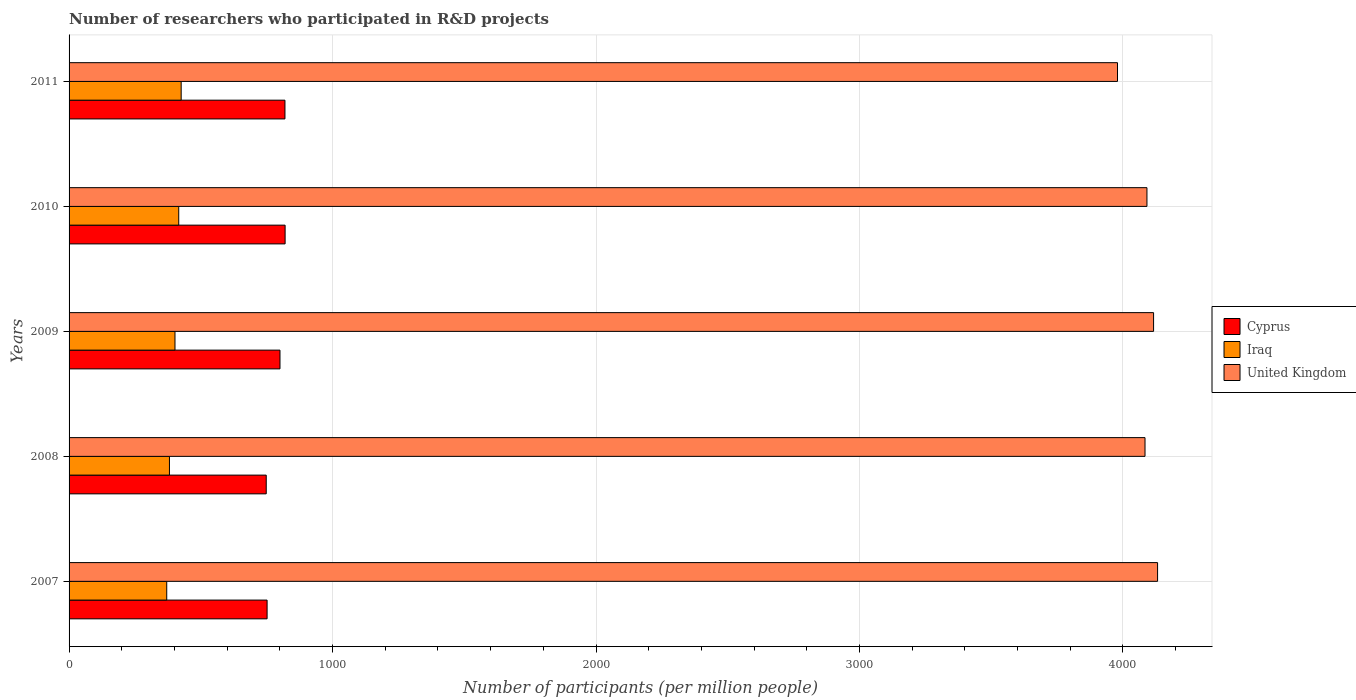How many groups of bars are there?
Your response must be concise. 5. Are the number of bars per tick equal to the number of legend labels?
Offer a very short reply. Yes. How many bars are there on the 2nd tick from the bottom?
Offer a terse response. 3. What is the label of the 4th group of bars from the top?
Your answer should be very brief. 2008. In how many cases, is the number of bars for a given year not equal to the number of legend labels?
Give a very brief answer. 0. What is the number of researchers who participated in R&D projects in United Kingdom in 2010?
Provide a succinct answer. 4091.18. Across all years, what is the maximum number of researchers who participated in R&D projects in United Kingdom?
Offer a terse response. 4131.53. Across all years, what is the minimum number of researchers who participated in R&D projects in Iraq?
Provide a succinct answer. 370.71. In which year was the number of researchers who participated in R&D projects in Cyprus maximum?
Offer a terse response. 2010. What is the total number of researchers who participated in R&D projects in Cyprus in the graph?
Give a very brief answer. 3939.95. What is the difference between the number of researchers who participated in R&D projects in United Kingdom in 2008 and that in 2010?
Provide a short and direct response. -7.32. What is the difference between the number of researchers who participated in R&D projects in Iraq in 2010 and the number of researchers who participated in R&D projects in United Kingdom in 2008?
Provide a succinct answer. -3667.6. What is the average number of researchers who participated in R&D projects in Cyprus per year?
Provide a short and direct response. 787.99. In the year 2011, what is the difference between the number of researchers who participated in R&D projects in United Kingdom and number of researchers who participated in R&D projects in Iraq?
Your answer should be compact. 3553.91. What is the ratio of the number of researchers who participated in R&D projects in Cyprus in 2008 to that in 2010?
Offer a very short reply. 0.91. Is the number of researchers who participated in R&D projects in Iraq in 2009 less than that in 2010?
Give a very brief answer. Yes. What is the difference between the highest and the second highest number of researchers who participated in R&D projects in Cyprus?
Provide a short and direct response. 0.56. What is the difference between the highest and the lowest number of researchers who participated in R&D projects in Cyprus?
Your response must be concise. 71.61. Is the sum of the number of researchers who participated in R&D projects in Cyprus in 2007 and 2011 greater than the maximum number of researchers who participated in R&D projects in United Kingdom across all years?
Your answer should be very brief. No. What does the 3rd bar from the top in 2007 represents?
Keep it short and to the point. Cyprus. What does the 3rd bar from the bottom in 2011 represents?
Offer a terse response. United Kingdom. Are the values on the major ticks of X-axis written in scientific E-notation?
Ensure brevity in your answer.  No. Does the graph contain any zero values?
Provide a succinct answer. No. Where does the legend appear in the graph?
Your response must be concise. Center right. How many legend labels are there?
Make the answer very short. 3. How are the legend labels stacked?
Ensure brevity in your answer.  Vertical. What is the title of the graph?
Your answer should be compact. Number of researchers who participated in R&D projects. Does "Timor-Leste" appear as one of the legend labels in the graph?
Offer a very short reply. No. What is the label or title of the X-axis?
Ensure brevity in your answer.  Number of participants (per million people). What is the label or title of the Y-axis?
Keep it short and to the point. Years. What is the Number of participants (per million people) of Cyprus in 2007?
Your answer should be very brief. 751.62. What is the Number of participants (per million people) in Iraq in 2007?
Offer a terse response. 370.71. What is the Number of participants (per million people) in United Kingdom in 2007?
Ensure brevity in your answer.  4131.53. What is the Number of participants (per million people) of Cyprus in 2008?
Keep it short and to the point. 748.37. What is the Number of participants (per million people) of Iraq in 2008?
Provide a succinct answer. 381.03. What is the Number of participants (per million people) of United Kingdom in 2008?
Your answer should be compact. 4083.86. What is the Number of participants (per million people) of Cyprus in 2009?
Your answer should be very brief. 800.56. What is the Number of participants (per million people) in Iraq in 2009?
Offer a terse response. 401.99. What is the Number of participants (per million people) of United Kingdom in 2009?
Offer a terse response. 4116.35. What is the Number of participants (per million people) of Cyprus in 2010?
Offer a very short reply. 819.98. What is the Number of participants (per million people) of Iraq in 2010?
Your response must be concise. 416.25. What is the Number of participants (per million people) in United Kingdom in 2010?
Your answer should be compact. 4091.18. What is the Number of participants (per million people) in Cyprus in 2011?
Give a very brief answer. 819.42. What is the Number of participants (per million people) of Iraq in 2011?
Provide a short and direct response. 425.48. What is the Number of participants (per million people) in United Kingdom in 2011?
Make the answer very short. 3979.38. Across all years, what is the maximum Number of participants (per million people) of Cyprus?
Your answer should be very brief. 819.98. Across all years, what is the maximum Number of participants (per million people) of Iraq?
Your answer should be very brief. 425.48. Across all years, what is the maximum Number of participants (per million people) of United Kingdom?
Make the answer very short. 4131.53. Across all years, what is the minimum Number of participants (per million people) in Cyprus?
Keep it short and to the point. 748.37. Across all years, what is the minimum Number of participants (per million people) of Iraq?
Give a very brief answer. 370.71. Across all years, what is the minimum Number of participants (per million people) of United Kingdom?
Keep it short and to the point. 3979.38. What is the total Number of participants (per million people) in Cyprus in the graph?
Make the answer very short. 3939.95. What is the total Number of participants (per million people) in Iraq in the graph?
Your answer should be very brief. 1995.47. What is the total Number of participants (per million people) of United Kingdom in the graph?
Keep it short and to the point. 2.04e+04. What is the difference between the Number of participants (per million people) of Cyprus in 2007 and that in 2008?
Offer a terse response. 3.25. What is the difference between the Number of participants (per million people) of Iraq in 2007 and that in 2008?
Provide a short and direct response. -10.31. What is the difference between the Number of participants (per million people) of United Kingdom in 2007 and that in 2008?
Keep it short and to the point. 47.67. What is the difference between the Number of participants (per million people) in Cyprus in 2007 and that in 2009?
Your answer should be compact. -48.94. What is the difference between the Number of participants (per million people) of Iraq in 2007 and that in 2009?
Your response must be concise. -31.28. What is the difference between the Number of participants (per million people) in United Kingdom in 2007 and that in 2009?
Make the answer very short. 15.18. What is the difference between the Number of participants (per million people) of Cyprus in 2007 and that in 2010?
Ensure brevity in your answer.  -68.36. What is the difference between the Number of participants (per million people) of Iraq in 2007 and that in 2010?
Give a very brief answer. -45.54. What is the difference between the Number of participants (per million people) in United Kingdom in 2007 and that in 2010?
Offer a very short reply. 40.36. What is the difference between the Number of participants (per million people) of Cyprus in 2007 and that in 2011?
Offer a very short reply. -67.8. What is the difference between the Number of participants (per million people) of Iraq in 2007 and that in 2011?
Ensure brevity in your answer.  -54.76. What is the difference between the Number of participants (per million people) of United Kingdom in 2007 and that in 2011?
Provide a succinct answer. 152.15. What is the difference between the Number of participants (per million people) in Cyprus in 2008 and that in 2009?
Your answer should be compact. -52.19. What is the difference between the Number of participants (per million people) of Iraq in 2008 and that in 2009?
Your response must be concise. -20.97. What is the difference between the Number of participants (per million people) in United Kingdom in 2008 and that in 2009?
Ensure brevity in your answer.  -32.49. What is the difference between the Number of participants (per million people) of Cyprus in 2008 and that in 2010?
Your response must be concise. -71.61. What is the difference between the Number of participants (per million people) in Iraq in 2008 and that in 2010?
Provide a succinct answer. -35.23. What is the difference between the Number of participants (per million people) of United Kingdom in 2008 and that in 2010?
Your answer should be compact. -7.32. What is the difference between the Number of participants (per million people) in Cyprus in 2008 and that in 2011?
Provide a succinct answer. -71.05. What is the difference between the Number of participants (per million people) in Iraq in 2008 and that in 2011?
Keep it short and to the point. -44.45. What is the difference between the Number of participants (per million people) of United Kingdom in 2008 and that in 2011?
Provide a succinct answer. 104.48. What is the difference between the Number of participants (per million people) of Cyprus in 2009 and that in 2010?
Give a very brief answer. -19.42. What is the difference between the Number of participants (per million people) in Iraq in 2009 and that in 2010?
Your answer should be compact. -14.26. What is the difference between the Number of participants (per million people) in United Kingdom in 2009 and that in 2010?
Your answer should be compact. 25.17. What is the difference between the Number of participants (per million people) of Cyprus in 2009 and that in 2011?
Give a very brief answer. -18.86. What is the difference between the Number of participants (per million people) of Iraq in 2009 and that in 2011?
Provide a succinct answer. -23.48. What is the difference between the Number of participants (per million people) in United Kingdom in 2009 and that in 2011?
Your answer should be very brief. 136.97. What is the difference between the Number of participants (per million people) in Cyprus in 2010 and that in 2011?
Your answer should be very brief. 0.56. What is the difference between the Number of participants (per million people) in Iraq in 2010 and that in 2011?
Provide a succinct answer. -9.22. What is the difference between the Number of participants (per million people) in United Kingdom in 2010 and that in 2011?
Give a very brief answer. 111.79. What is the difference between the Number of participants (per million people) in Cyprus in 2007 and the Number of participants (per million people) in Iraq in 2008?
Provide a succinct answer. 370.59. What is the difference between the Number of participants (per million people) of Cyprus in 2007 and the Number of participants (per million people) of United Kingdom in 2008?
Ensure brevity in your answer.  -3332.24. What is the difference between the Number of participants (per million people) of Iraq in 2007 and the Number of participants (per million people) of United Kingdom in 2008?
Provide a short and direct response. -3713.14. What is the difference between the Number of participants (per million people) of Cyprus in 2007 and the Number of participants (per million people) of Iraq in 2009?
Offer a very short reply. 349.62. What is the difference between the Number of participants (per million people) in Cyprus in 2007 and the Number of participants (per million people) in United Kingdom in 2009?
Keep it short and to the point. -3364.73. What is the difference between the Number of participants (per million people) in Iraq in 2007 and the Number of participants (per million people) in United Kingdom in 2009?
Give a very brief answer. -3745.64. What is the difference between the Number of participants (per million people) in Cyprus in 2007 and the Number of participants (per million people) in Iraq in 2010?
Provide a succinct answer. 335.36. What is the difference between the Number of participants (per million people) of Cyprus in 2007 and the Number of participants (per million people) of United Kingdom in 2010?
Give a very brief answer. -3339.56. What is the difference between the Number of participants (per million people) of Iraq in 2007 and the Number of participants (per million people) of United Kingdom in 2010?
Ensure brevity in your answer.  -3720.46. What is the difference between the Number of participants (per million people) in Cyprus in 2007 and the Number of participants (per million people) in Iraq in 2011?
Keep it short and to the point. 326.14. What is the difference between the Number of participants (per million people) in Cyprus in 2007 and the Number of participants (per million people) in United Kingdom in 2011?
Give a very brief answer. -3227.77. What is the difference between the Number of participants (per million people) in Iraq in 2007 and the Number of participants (per million people) in United Kingdom in 2011?
Make the answer very short. -3608.67. What is the difference between the Number of participants (per million people) of Cyprus in 2008 and the Number of participants (per million people) of Iraq in 2009?
Keep it short and to the point. 346.37. What is the difference between the Number of participants (per million people) of Cyprus in 2008 and the Number of participants (per million people) of United Kingdom in 2009?
Offer a very short reply. -3367.98. What is the difference between the Number of participants (per million people) of Iraq in 2008 and the Number of participants (per million people) of United Kingdom in 2009?
Provide a short and direct response. -3735.32. What is the difference between the Number of participants (per million people) of Cyprus in 2008 and the Number of participants (per million people) of Iraq in 2010?
Provide a short and direct response. 332.11. What is the difference between the Number of participants (per million people) in Cyprus in 2008 and the Number of participants (per million people) in United Kingdom in 2010?
Offer a terse response. -3342.81. What is the difference between the Number of participants (per million people) of Iraq in 2008 and the Number of participants (per million people) of United Kingdom in 2010?
Provide a succinct answer. -3710.15. What is the difference between the Number of participants (per million people) in Cyprus in 2008 and the Number of participants (per million people) in Iraq in 2011?
Keep it short and to the point. 322.89. What is the difference between the Number of participants (per million people) of Cyprus in 2008 and the Number of participants (per million people) of United Kingdom in 2011?
Keep it short and to the point. -3231.02. What is the difference between the Number of participants (per million people) in Iraq in 2008 and the Number of participants (per million people) in United Kingdom in 2011?
Keep it short and to the point. -3598.36. What is the difference between the Number of participants (per million people) of Cyprus in 2009 and the Number of participants (per million people) of Iraq in 2010?
Your answer should be very brief. 384.31. What is the difference between the Number of participants (per million people) in Cyprus in 2009 and the Number of participants (per million people) in United Kingdom in 2010?
Your answer should be very brief. -3290.61. What is the difference between the Number of participants (per million people) of Iraq in 2009 and the Number of participants (per million people) of United Kingdom in 2010?
Provide a short and direct response. -3689.18. What is the difference between the Number of participants (per million people) in Cyprus in 2009 and the Number of participants (per million people) in Iraq in 2011?
Your answer should be very brief. 375.08. What is the difference between the Number of participants (per million people) in Cyprus in 2009 and the Number of participants (per million people) in United Kingdom in 2011?
Your response must be concise. -3178.82. What is the difference between the Number of participants (per million people) of Iraq in 2009 and the Number of participants (per million people) of United Kingdom in 2011?
Give a very brief answer. -3577.39. What is the difference between the Number of participants (per million people) of Cyprus in 2010 and the Number of participants (per million people) of Iraq in 2011?
Offer a very short reply. 394.5. What is the difference between the Number of participants (per million people) of Cyprus in 2010 and the Number of participants (per million people) of United Kingdom in 2011?
Make the answer very short. -3159.4. What is the difference between the Number of participants (per million people) of Iraq in 2010 and the Number of participants (per million people) of United Kingdom in 2011?
Offer a very short reply. -3563.13. What is the average Number of participants (per million people) in Cyprus per year?
Make the answer very short. 787.99. What is the average Number of participants (per million people) in Iraq per year?
Your response must be concise. 399.09. What is the average Number of participants (per million people) of United Kingdom per year?
Ensure brevity in your answer.  4080.46. In the year 2007, what is the difference between the Number of participants (per million people) of Cyprus and Number of participants (per million people) of Iraq?
Offer a terse response. 380.9. In the year 2007, what is the difference between the Number of participants (per million people) in Cyprus and Number of participants (per million people) in United Kingdom?
Offer a terse response. -3379.92. In the year 2007, what is the difference between the Number of participants (per million people) of Iraq and Number of participants (per million people) of United Kingdom?
Your answer should be very brief. -3760.82. In the year 2008, what is the difference between the Number of participants (per million people) in Cyprus and Number of participants (per million people) in Iraq?
Your answer should be compact. 367.34. In the year 2008, what is the difference between the Number of participants (per million people) in Cyprus and Number of participants (per million people) in United Kingdom?
Provide a succinct answer. -3335.49. In the year 2008, what is the difference between the Number of participants (per million people) of Iraq and Number of participants (per million people) of United Kingdom?
Your response must be concise. -3702.83. In the year 2009, what is the difference between the Number of participants (per million people) in Cyprus and Number of participants (per million people) in Iraq?
Provide a succinct answer. 398.57. In the year 2009, what is the difference between the Number of participants (per million people) in Cyprus and Number of participants (per million people) in United Kingdom?
Provide a succinct answer. -3315.79. In the year 2009, what is the difference between the Number of participants (per million people) in Iraq and Number of participants (per million people) in United Kingdom?
Your answer should be very brief. -3714.36. In the year 2010, what is the difference between the Number of participants (per million people) in Cyprus and Number of participants (per million people) in Iraq?
Provide a succinct answer. 403.73. In the year 2010, what is the difference between the Number of participants (per million people) in Cyprus and Number of participants (per million people) in United Kingdom?
Offer a terse response. -3271.2. In the year 2010, what is the difference between the Number of participants (per million people) in Iraq and Number of participants (per million people) in United Kingdom?
Your answer should be compact. -3674.92. In the year 2011, what is the difference between the Number of participants (per million people) in Cyprus and Number of participants (per million people) in Iraq?
Make the answer very short. 393.94. In the year 2011, what is the difference between the Number of participants (per million people) in Cyprus and Number of participants (per million people) in United Kingdom?
Your answer should be compact. -3159.96. In the year 2011, what is the difference between the Number of participants (per million people) of Iraq and Number of participants (per million people) of United Kingdom?
Offer a terse response. -3553.91. What is the ratio of the Number of participants (per million people) in Cyprus in 2007 to that in 2008?
Your response must be concise. 1. What is the ratio of the Number of participants (per million people) of Iraq in 2007 to that in 2008?
Your answer should be compact. 0.97. What is the ratio of the Number of participants (per million people) of United Kingdom in 2007 to that in 2008?
Make the answer very short. 1.01. What is the ratio of the Number of participants (per million people) of Cyprus in 2007 to that in 2009?
Make the answer very short. 0.94. What is the ratio of the Number of participants (per million people) in Iraq in 2007 to that in 2009?
Your response must be concise. 0.92. What is the ratio of the Number of participants (per million people) in Cyprus in 2007 to that in 2010?
Your response must be concise. 0.92. What is the ratio of the Number of participants (per million people) in Iraq in 2007 to that in 2010?
Provide a succinct answer. 0.89. What is the ratio of the Number of participants (per million people) in United Kingdom in 2007 to that in 2010?
Provide a succinct answer. 1.01. What is the ratio of the Number of participants (per million people) in Cyprus in 2007 to that in 2011?
Provide a succinct answer. 0.92. What is the ratio of the Number of participants (per million people) of Iraq in 2007 to that in 2011?
Your answer should be compact. 0.87. What is the ratio of the Number of participants (per million people) in United Kingdom in 2007 to that in 2011?
Give a very brief answer. 1.04. What is the ratio of the Number of participants (per million people) of Cyprus in 2008 to that in 2009?
Give a very brief answer. 0.93. What is the ratio of the Number of participants (per million people) in Iraq in 2008 to that in 2009?
Provide a succinct answer. 0.95. What is the ratio of the Number of participants (per million people) of United Kingdom in 2008 to that in 2009?
Keep it short and to the point. 0.99. What is the ratio of the Number of participants (per million people) in Cyprus in 2008 to that in 2010?
Keep it short and to the point. 0.91. What is the ratio of the Number of participants (per million people) in Iraq in 2008 to that in 2010?
Offer a terse response. 0.92. What is the ratio of the Number of participants (per million people) of United Kingdom in 2008 to that in 2010?
Provide a short and direct response. 1. What is the ratio of the Number of participants (per million people) in Cyprus in 2008 to that in 2011?
Your response must be concise. 0.91. What is the ratio of the Number of participants (per million people) in Iraq in 2008 to that in 2011?
Make the answer very short. 0.9. What is the ratio of the Number of participants (per million people) of United Kingdom in 2008 to that in 2011?
Ensure brevity in your answer.  1.03. What is the ratio of the Number of participants (per million people) in Cyprus in 2009 to that in 2010?
Your response must be concise. 0.98. What is the ratio of the Number of participants (per million people) of Iraq in 2009 to that in 2010?
Give a very brief answer. 0.97. What is the ratio of the Number of participants (per million people) of United Kingdom in 2009 to that in 2010?
Ensure brevity in your answer.  1.01. What is the ratio of the Number of participants (per million people) in Iraq in 2009 to that in 2011?
Keep it short and to the point. 0.94. What is the ratio of the Number of participants (per million people) in United Kingdom in 2009 to that in 2011?
Offer a terse response. 1.03. What is the ratio of the Number of participants (per million people) of Cyprus in 2010 to that in 2011?
Make the answer very short. 1. What is the ratio of the Number of participants (per million people) of Iraq in 2010 to that in 2011?
Your answer should be compact. 0.98. What is the ratio of the Number of participants (per million people) in United Kingdom in 2010 to that in 2011?
Your answer should be compact. 1.03. What is the difference between the highest and the second highest Number of participants (per million people) in Cyprus?
Make the answer very short. 0.56. What is the difference between the highest and the second highest Number of participants (per million people) of Iraq?
Make the answer very short. 9.22. What is the difference between the highest and the second highest Number of participants (per million people) of United Kingdom?
Ensure brevity in your answer.  15.18. What is the difference between the highest and the lowest Number of participants (per million people) of Cyprus?
Offer a very short reply. 71.61. What is the difference between the highest and the lowest Number of participants (per million people) of Iraq?
Your answer should be very brief. 54.76. What is the difference between the highest and the lowest Number of participants (per million people) of United Kingdom?
Your answer should be compact. 152.15. 